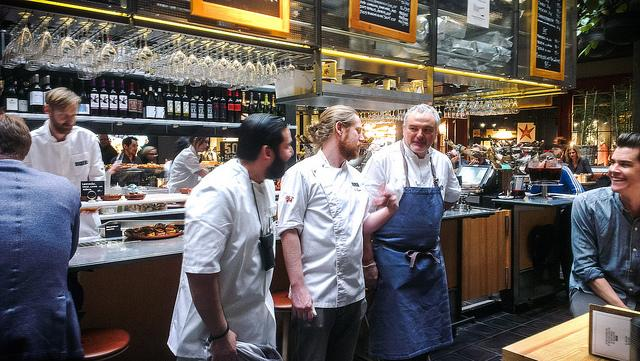What profession are the men wearing aprons? chefs 